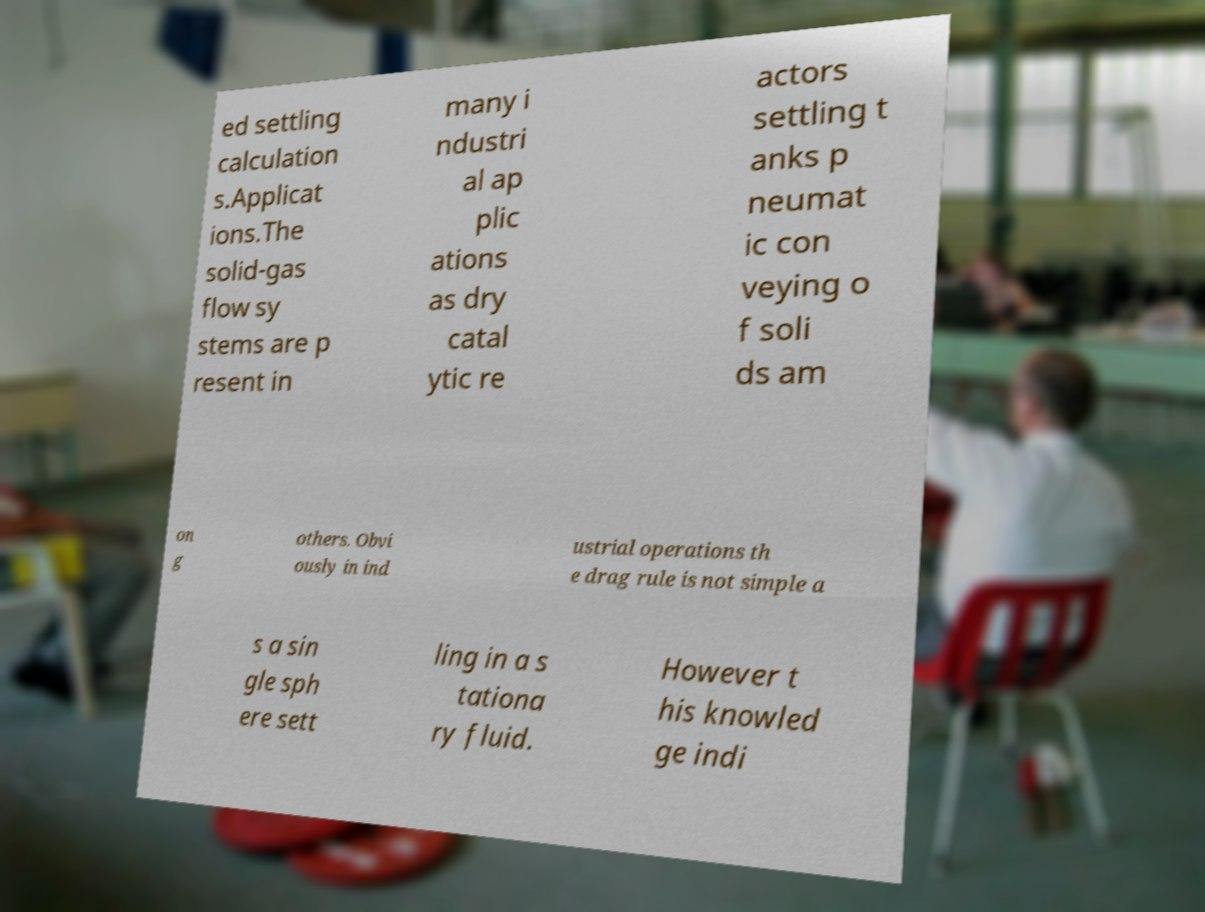Please identify and transcribe the text found in this image. ed settling calculation s.Applicat ions.The solid-gas flow sy stems are p resent in many i ndustri al ap plic ations as dry catal ytic re actors settling t anks p neumat ic con veying o f soli ds am on g others. Obvi ously in ind ustrial operations th e drag rule is not simple a s a sin gle sph ere sett ling in a s tationa ry fluid. However t his knowled ge indi 